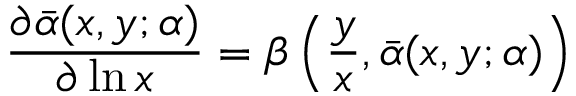Convert formula to latex. <formula><loc_0><loc_0><loc_500><loc_500>\frac { \partial \bar { \alpha } ( x , y ; \alpha ) } { \partial \ln x } = \beta \left ( \frac { y } { x } , \bar { \alpha } ( x , y ; \alpha ) \right )</formula> 